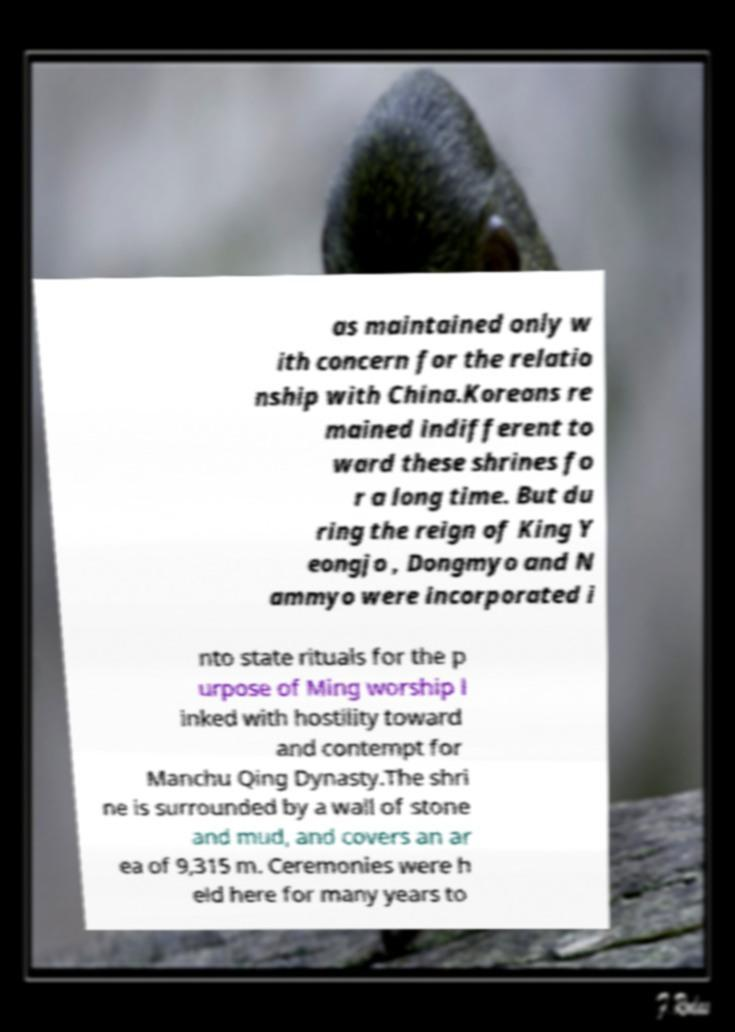For documentation purposes, I need the text within this image transcribed. Could you provide that? as maintained only w ith concern for the relatio nship with China.Koreans re mained indifferent to ward these shrines fo r a long time. But du ring the reign of King Y eongjo , Dongmyo and N ammyo were incorporated i nto state rituals for the p urpose of Ming worship l inked with hostility toward and contempt for Manchu Qing Dynasty.The shri ne is surrounded by a wall of stone and mud, and covers an ar ea of 9,315 m. Ceremonies were h eld here for many years to 